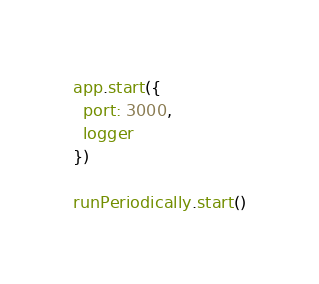Convert code to text. <code><loc_0><loc_0><loc_500><loc_500><_JavaScript_>app.start({
  port: 3000,
  logger
})

runPeriodically.start()
</code> 